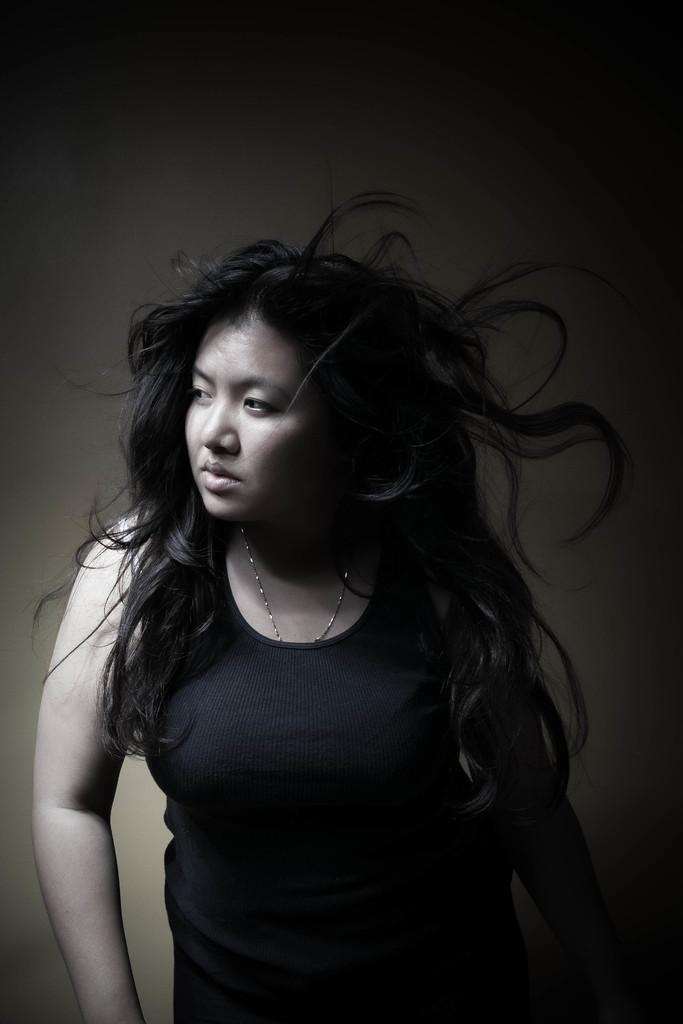What is the color scheme of the image? The image is black and white. Can you describe the person in the image? There is a woman in the image. What is the woman wearing? The woman is wearing a black dress. What type of cap is the woman wearing in the image? There is no cap visible in the image; the woman is wearing a black dress. Can you see any mist in the image? There is no mist present in the image; it is a black and white image of a woman wearing a black dress. 